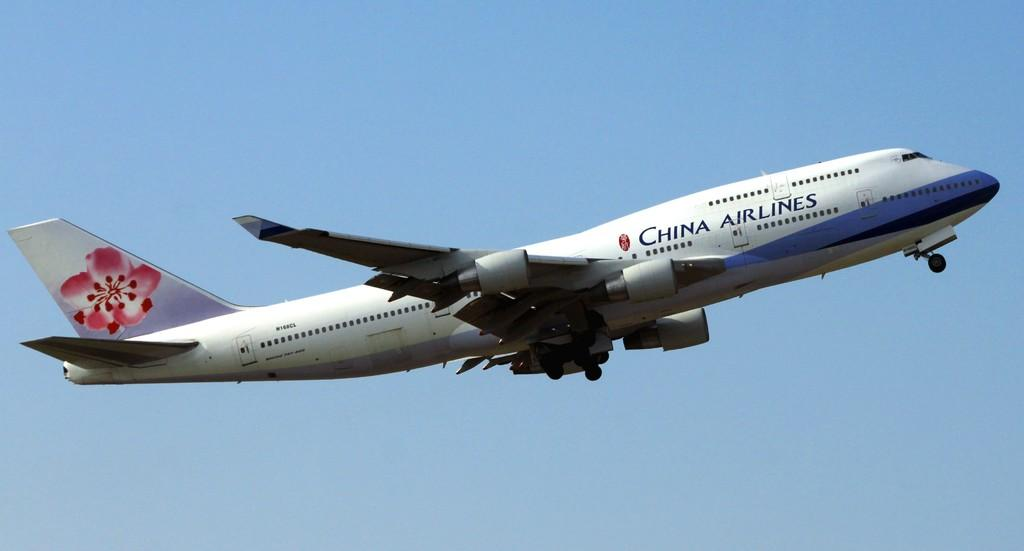<image>
Create a compact narrative representing the image presented. China Airlines blue and white airplane with flower designs on the back. 